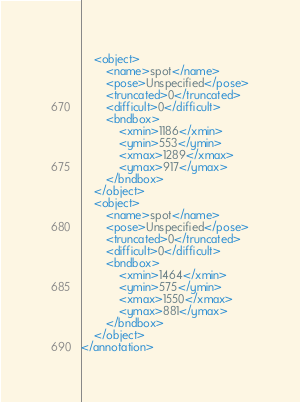Convert code to text. <code><loc_0><loc_0><loc_500><loc_500><_XML_>	<object>
		<name>spot</name>
		<pose>Unspecified</pose>
		<truncated>0</truncated>
		<difficult>0</difficult>
		<bndbox>
			<xmin>1186</xmin>
			<ymin>553</ymin>
			<xmax>1289</xmax>
			<ymax>917</ymax>
		</bndbox>
	</object>
	<object>
		<name>spot</name>
		<pose>Unspecified</pose>
		<truncated>0</truncated>
		<difficult>0</difficult>
		<bndbox>
			<xmin>1464</xmin>
			<ymin>575</ymin>
			<xmax>1550</xmax>
			<ymax>881</ymax>
		</bndbox>
	</object>
</annotation>
</code> 